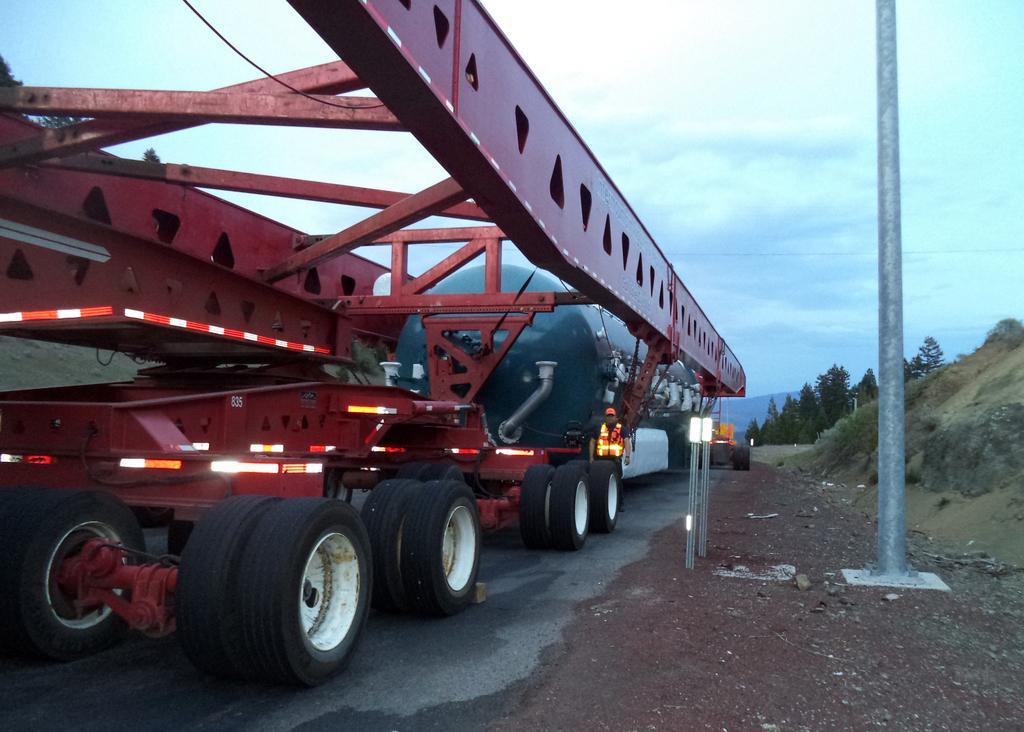Please provide a concise description of this image. In this image I can see vehicles on the road and I can see a person visible in front of the vehicle and I can see a pole and the sky and the hill ,tree visible. 